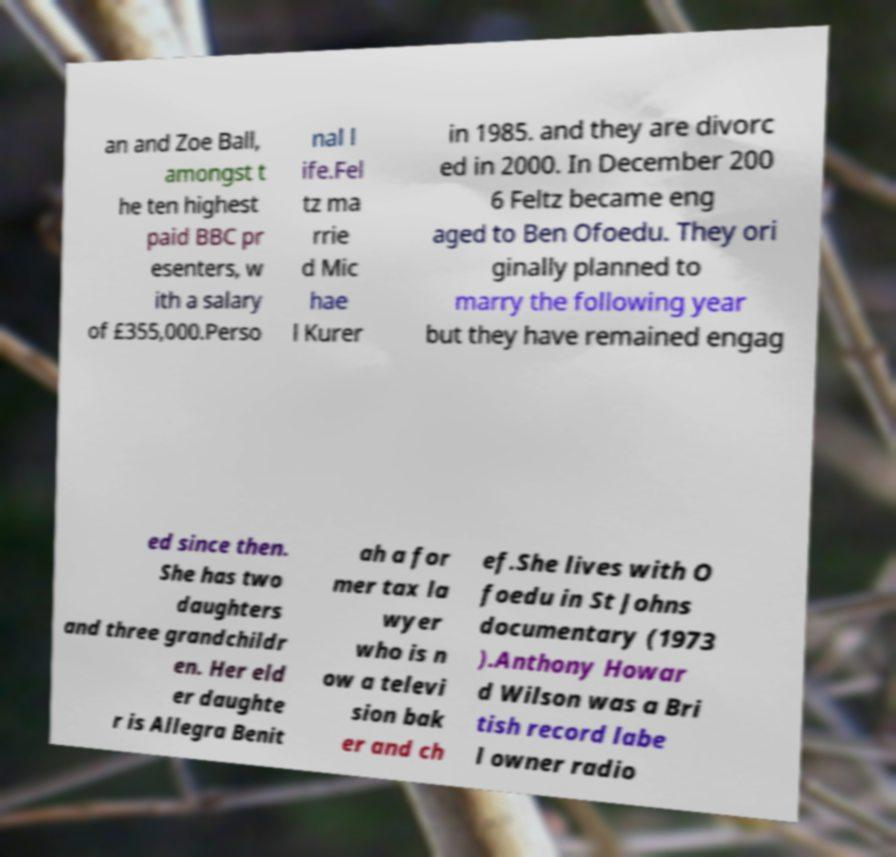I need the written content from this picture converted into text. Can you do that? an and Zoe Ball, amongst t he ten highest paid BBC pr esenters, w ith a salary of £355,000.Perso nal l ife.Fel tz ma rrie d Mic hae l Kurer in 1985. and they are divorc ed in 2000. In December 200 6 Feltz became eng aged to Ben Ofoedu. They ori ginally planned to marry the following year but they have remained engag ed since then. She has two daughters and three grandchildr en. Her eld er daughte r is Allegra Benit ah a for mer tax la wyer who is n ow a televi sion bak er and ch ef.She lives with O foedu in St Johns documentary (1973 ).Anthony Howar d Wilson was a Bri tish record labe l owner radio 